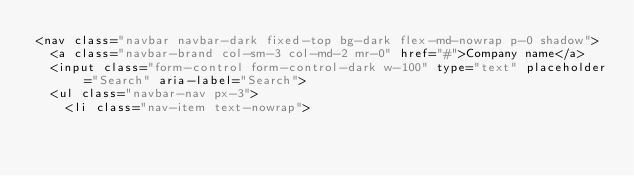<code> <loc_0><loc_0><loc_500><loc_500><_PHP_><nav class="navbar navbar-dark fixed-top bg-dark flex-md-nowrap p-0 shadow">
  <a class="navbar-brand col-sm-3 col-md-2 mr-0" href="#">Company name</a>
  <input class="form-control form-control-dark w-100" type="text" placeholder="Search" aria-label="Search">
  <ul class="navbar-nav px-3">
    <li class="nav-item text-nowrap"></code> 